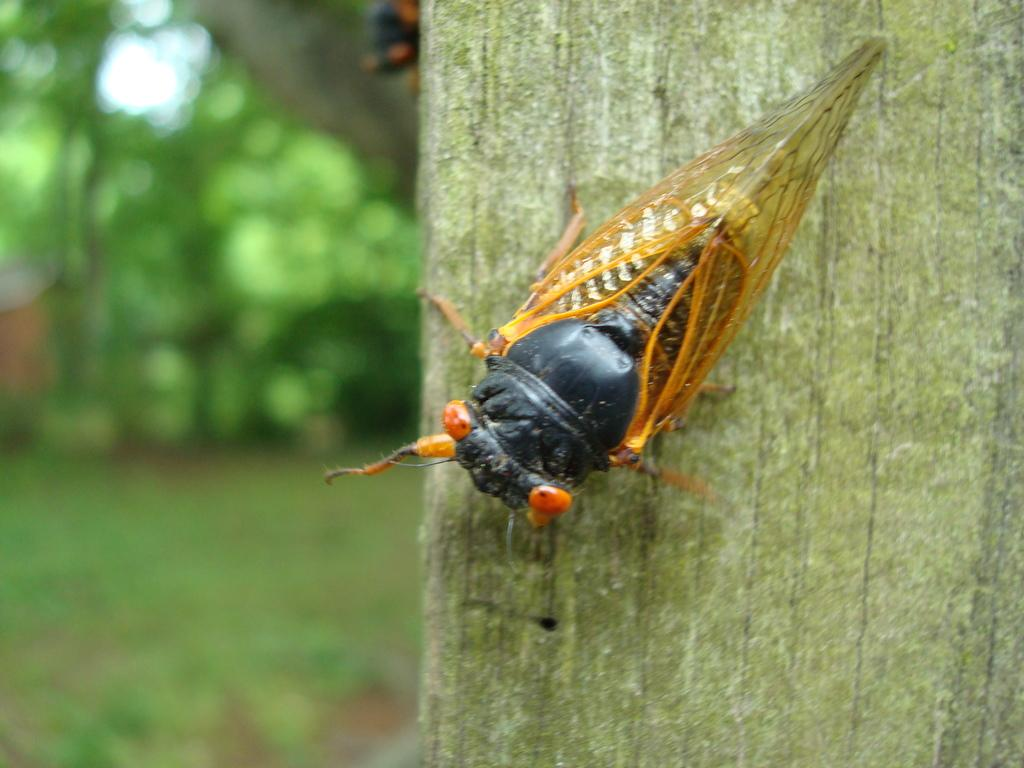What type of creature can be seen in the image? There is an insect in the image. Can you describe the background of the image? The background of the image is blurry. What type of tub is visible in the image? There is no tub present in the image; it only features an insect and a blurry background. What subject is being taught in the image? There is no teaching activity depicted in the image; it only features an insect and a blurry background. 